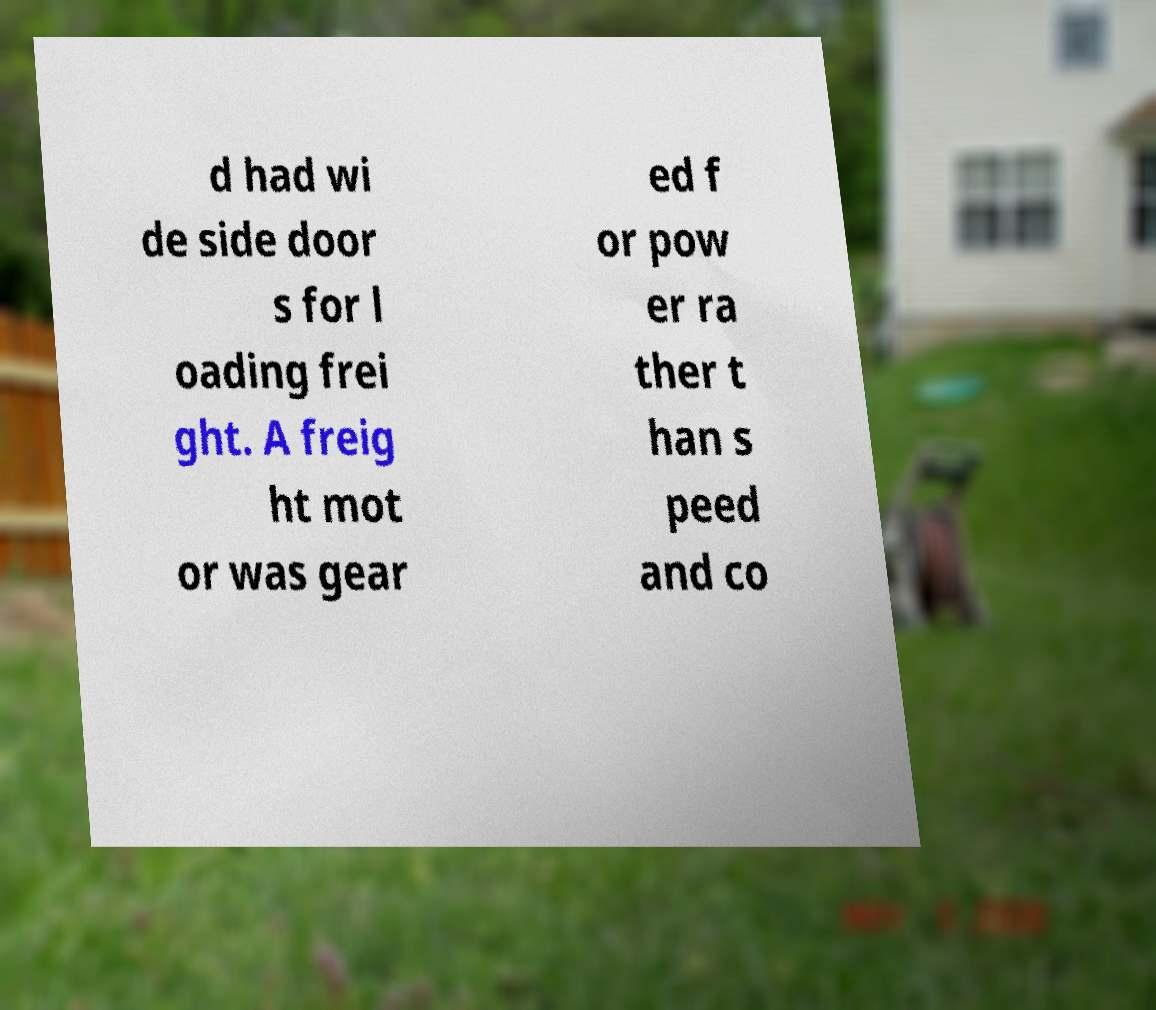For documentation purposes, I need the text within this image transcribed. Could you provide that? d had wi de side door s for l oading frei ght. A freig ht mot or was gear ed f or pow er ra ther t han s peed and co 